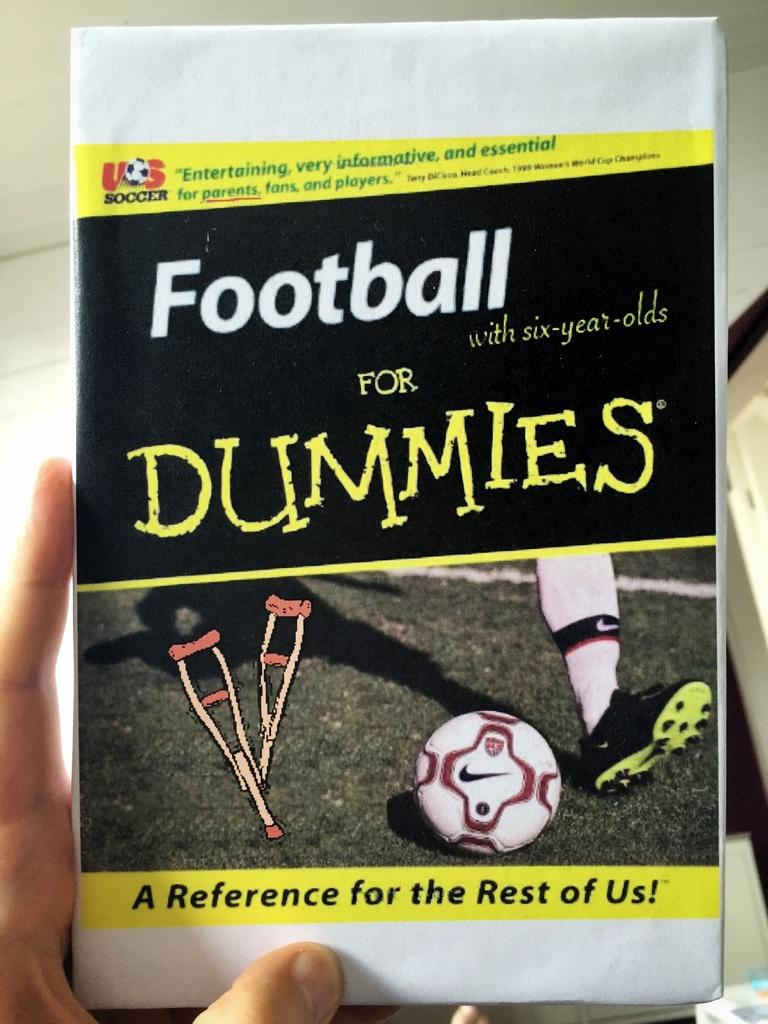<image>
Write a terse but informative summary of the picture. A Football For Dummies geared towards six-year-olds is being held up. 